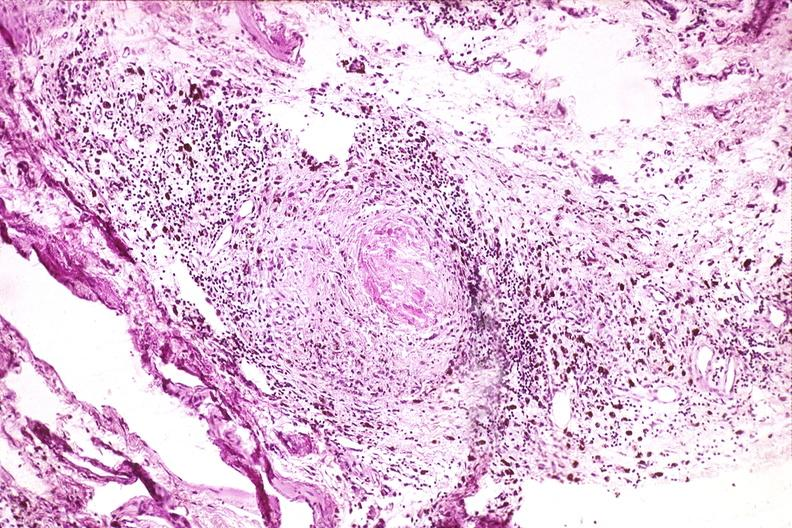what is present?
Answer the question using a single word or phrase. Musculoskeletal 